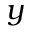<formula> <loc_0><loc_0><loc_500><loc_500>y</formula> 